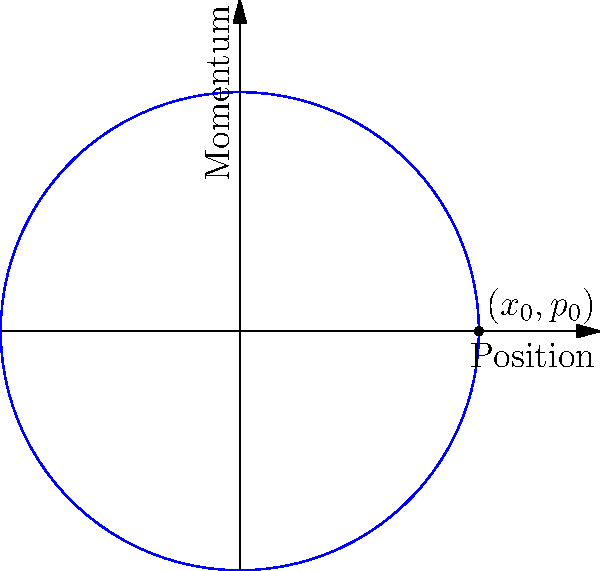Consider a simple harmonic oscillator with mass $m=1$ kg and spring constant $k=1$ N/m. Given the phase space trajectory shown in the diagram, determine the total energy of the system in Joules. To find the total energy of the simple harmonic oscillator, we'll follow these steps:

1) The phase space trajectory is a circle, which is typical for a simple harmonic oscillator. The x-axis represents position (x), and the y-axis represents momentum (p).

2) The radius of the circle represents the amplitude of oscillation. From the diagram, we can see that the maximum displacement is 2 units.

3) For a simple harmonic oscillator, the total energy is constant and is the sum of kinetic and potential energies:

   $$E = \frac{1}{2}kx^2 + \frac{p^2}{2m}$$

4) At the point $(x_0,p_0) = (2,0)$, all energy is potential. We can use this to calculate the total energy:

   $$E = \frac{1}{2}kx_0^2 = \frac{1}{2} \cdot 1 \cdot 2^2 = 2\text{ J}$$

5) We can verify this by checking another point. At $(0,\pm2)$, all energy is kinetic:

   $$E = \frac{p^2}{2m} = \frac{(\pm2)^2}{2\cdot1} = 2\text{ J}$$

Thus, the total energy of the system is 2 Joules.
Answer: 2 J 